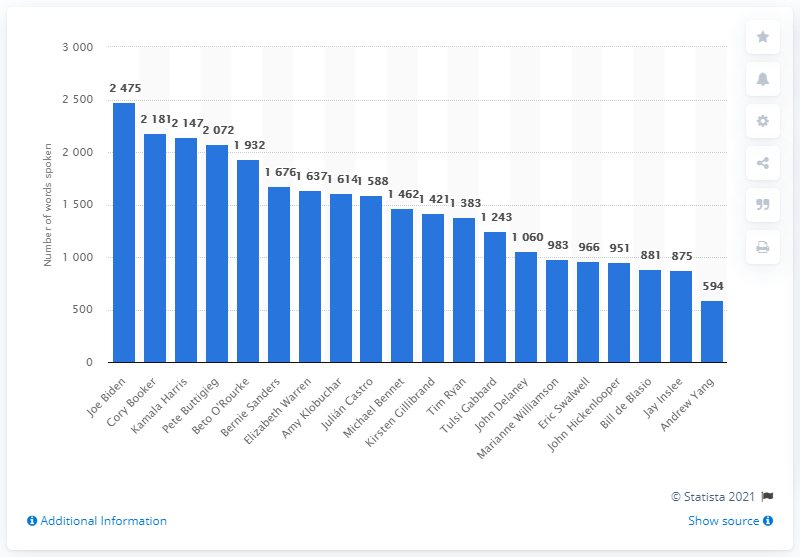Mention a couple of crucial points in this snapshot. Who was the candidate who spoke the most during the first televised debates? It was Joe Biden. 